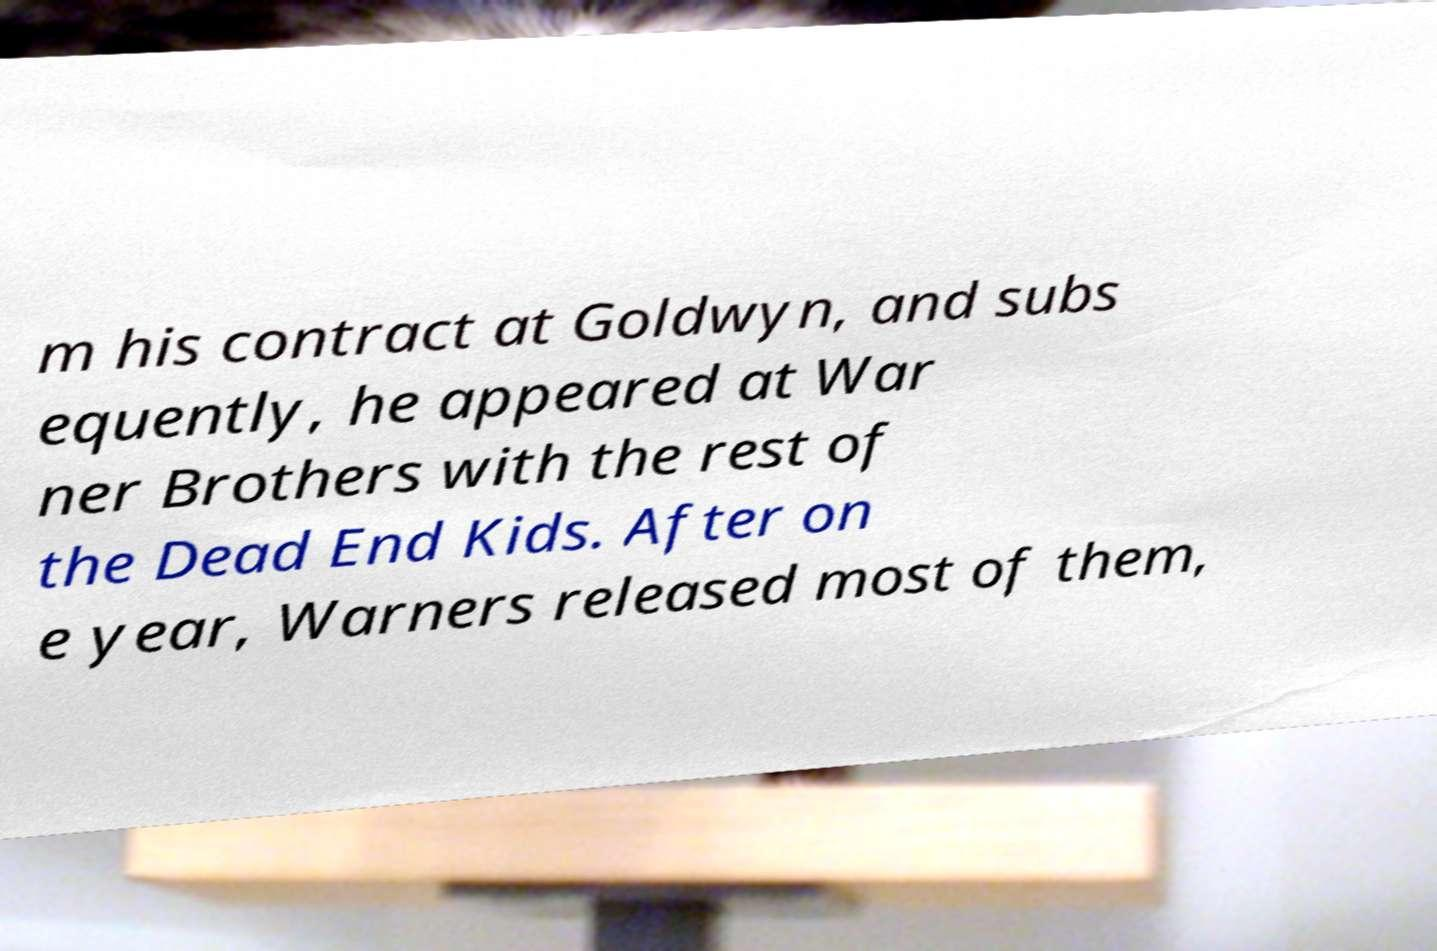Please read and relay the text visible in this image. What does it say? m his contract at Goldwyn, and subs equently, he appeared at War ner Brothers with the rest of the Dead End Kids. After on e year, Warners released most of them, 